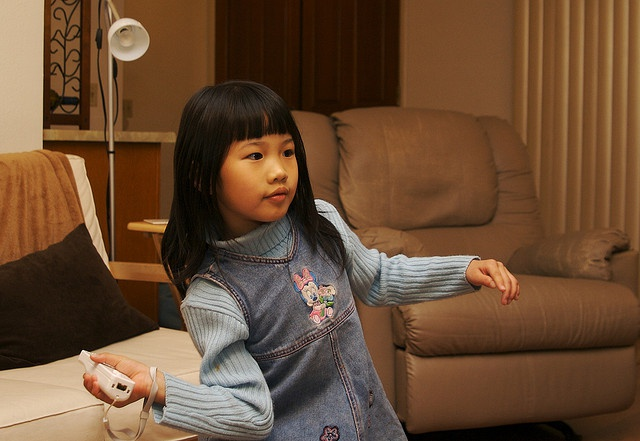Describe the objects in this image and their specific colors. I can see chair in tan, maroon, brown, and black tones, people in tan, black, gray, darkgray, and maroon tones, couch in tan, black, and brown tones, and remote in tan and lightgray tones in this image. 